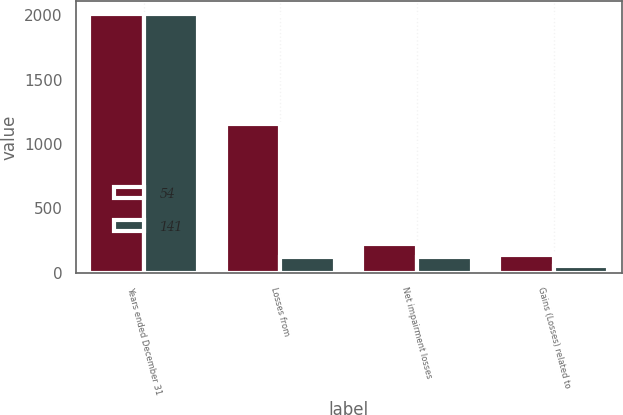<chart> <loc_0><loc_0><loc_500><loc_500><stacked_bar_chart><ecel><fcel>Years ended December 31<fcel>Losses from<fcel>Net impairment losses<fcel>Gains (Losses) related to<nl><fcel>54<fcel>2009<fcel>1155<fcel>227<fcel>141<nl><fcel>141<fcel>2008<fcel>122<fcel>122<fcel>54<nl></chart> 